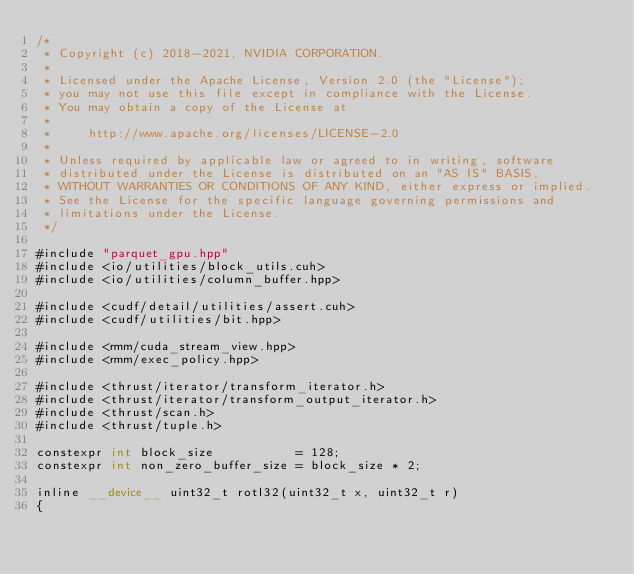<code> <loc_0><loc_0><loc_500><loc_500><_Cuda_>/*
 * Copyright (c) 2018-2021, NVIDIA CORPORATION.
 *
 * Licensed under the Apache License, Version 2.0 (the "License");
 * you may not use this file except in compliance with the License.
 * You may obtain a copy of the License at
 *
 *     http://www.apache.org/licenses/LICENSE-2.0
 *
 * Unless required by applicable law or agreed to in writing, software
 * distributed under the License is distributed on an "AS IS" BASIS,
 * WITHOUT WARRANTIES OR CONDITIONS OF ANY KIND, either express or implied.
 * See the License for the specific language governing permissions and
 * limitations under the License.
 */

#include "parquet_gpu.hpp"
#include <io/utilities/block_utils.cuh>
#include <io/utilities/column_buffer.hpp>

#include <cudf/detail/utilities/assert.cuh>
#include <cudf/utilities/bit.hpp>

#include <rmm/cuda_stream_view.hpp>
#include <rmm/exec_policy.hpp>

#include <thrust/iterator/transform_iterator.h>
#include <thrust/iterator/transform_output_iterator.h>
#include <thrust/scan.h>
#include <thrust/tuple.h>

constexpr int block_size           = 128;
constexpr int non_zero_buffer_size = block_size * 2;

inline __device__ uint32_t rotl32(uint32_t x, uint32_t r)
{</code> 